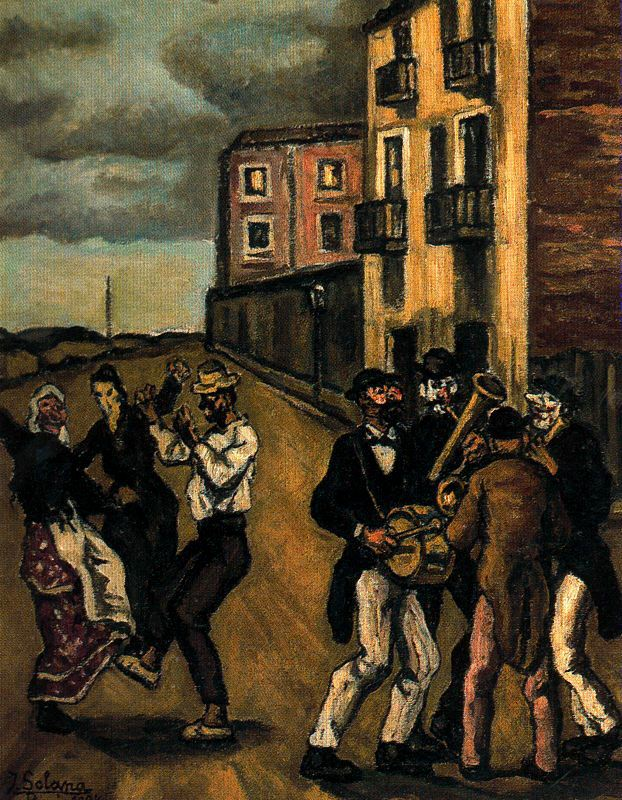Can you describe the main features of this image for me? The image depicts a vibrant street scene of a group of people dancing outdoors, rendered in a post-impressionistic style with influences of social realism. The people, dressed in traditional attire, are joyfully dancing to the tunes played by musicians comprising a drummer and a clarinet player. The dark and earthy color palette of the painting adds depth and highlights the contrast with the bright colors of the clothing. The background features tall buildings adorned with numerous windows, set under a deep blue night sky that enhances the nocturnal ambiance. The signature of the artist, 'Soler,' is inscribed in the bottom left corner, adding a personal touch to this lively depiction of communal celebration. 